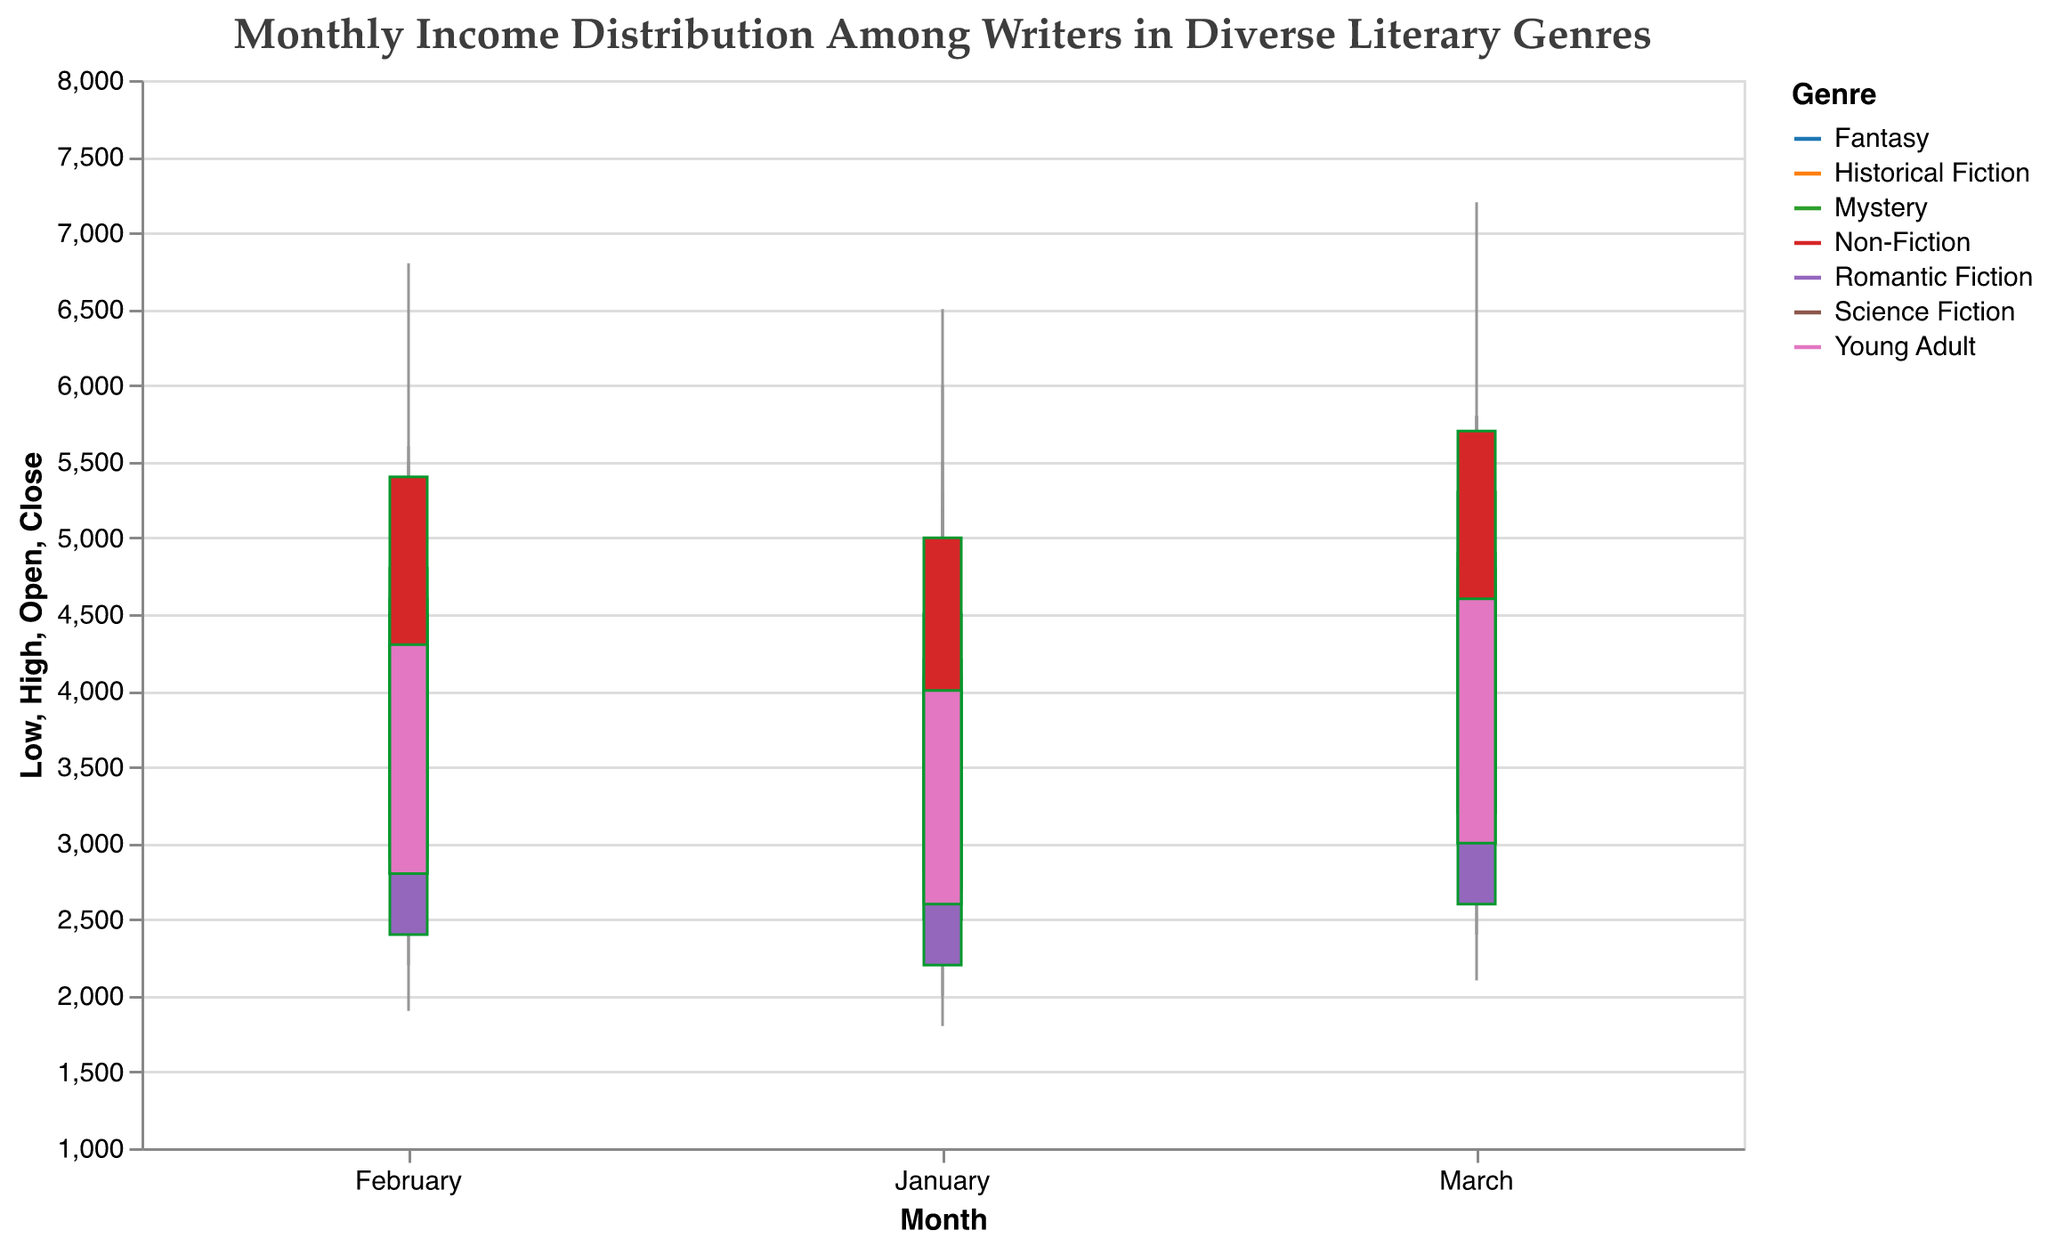What is the title of the figure? The title of the figure is mentioned at the top of the plot. It is "Monthly Income Distribution Among Writers in Diverse Literary Genres."
Answer: Monthly Income Distribution Among Writers in Diverse Literary Genres How many genres are represented in this candlestick plot? The genres are represented by different colors in the legend. The plot includes seven genres: Science Fiction, Fantasy, Mystery, Romantic Fiction, Historical Fiction, Non-Fiction, and Young Adult.
Answer: Seven What is the highest recorded income in March for Non-Fiction writers? To find the highest recorded income for Non-Fiction writers in March, look at the highest point on the candle for the Non-Fiction genre in March, which is represented by the candlestick's "High" value. The highest income recorded is 7200.
Answer: 7200 Compare the income range for January between Science Fiction and Fantasy writers. Which genre has a wider income range? To determine the income range, subtract the "Low" value from the "High" value for each genre in January. For Science Fiction: (6000-2500) = 3500. For Fantasy: (5000-2000) = 3000. Science Fiction has a wider income range.
Answer: Science Fiction Between which months did the income for Mystery writers increase the most? To find the month with the greatest increase, look at the "Close" value of the previous month and the "Open" value of the current month. Compare the increase between each month: from January to February (4500-4200 = 300) and February to March (4900-4500 = 400). The highest increase is from February to March.
Answer: February to March Which genre had the least variability in income for March, and what was the range? Variability can be assessed by the range, calculated as the difference between the "High" and "Low" values. March values are: Science Fiction (5800-2700=3100), Fantasy (5300-2400=2900), Mystery (5800-2600=3200), Romantic Fiction (5200-2100=3100), Historical Fiction (5800-2800=3000), Non-Fiction (7200-3500=3700), Young Adult (5700-2600=3100). Fantasy has the least variability with a range of 2900.
Answer: Fantasy, 2900 Which genre experienced the highest closing income in February? Check the "Close" values for each genre in February. The values are: Science Fiction (4800), Fantasy (4600), Mystery (4500), Romantic Fiction (4000), Historical Fiction (4500), Non-Fiction (5400), Young Adult (4300). The highest closing income in February is for Non-Fiction writers.
Answer: Non-Fiction What is the average closing income for Young Adult writers over the three months? To find the average closing income, add the "Close" values for January, February, and March, and divide by 3. For Young Adult: (4000 + 4300 + 4600) / 3 = 12900 / 3 = 4300.
Answer: 4300 Which genre had a decline in closing income from February to March? To identify the decline, compare the "Close" values from February to March for each genre. The only genre showing a decline is Non-Fiction from 5400 in February to 5700 in March. All other genres show an increase in their closing income.
Answer: None What is the difference between the highest and lowest monthly opening incomes for Historical Fiction writers? Find the "Open" values across the three months for Historical Fiction: January (2800), February (3000), March (3200). The difference between the highest (3200) and the lowest (2800) opening income is 3200 - 2800 = 400.
Answer: 400 